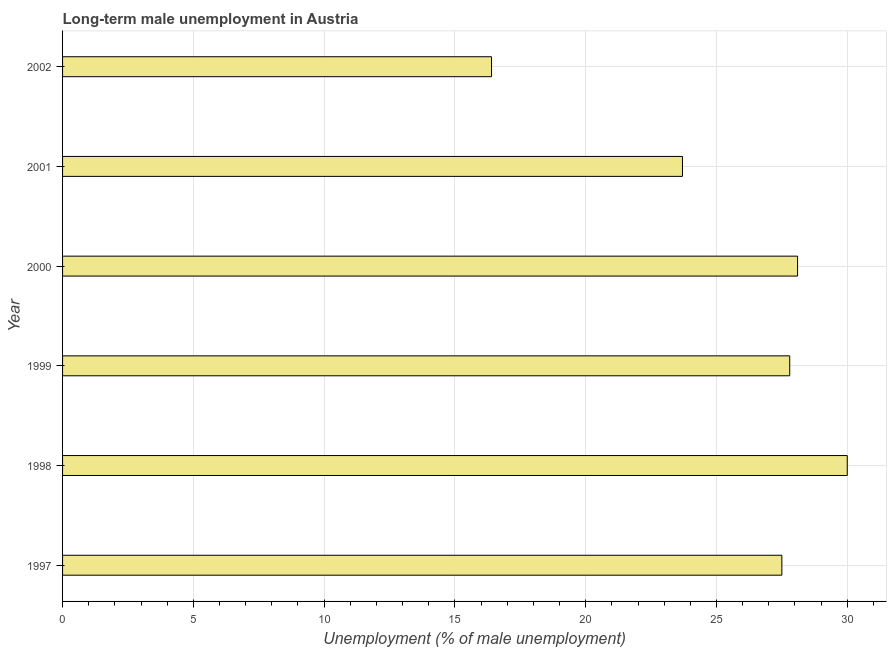Does the graph contain any zero values?
Your response must be concise. No. What is the title of the graph?
Provide a short and direct response. Long-term male unemployment in Austria. What is the label or title of the X-axis?
Your answer should be compact. Unemployment (% of male unemployment). What is the long-term male unemployment in 2000?
Offer a very short reply. 28.1. Across all years, what is the maximum long-term male unemployment?
Provide a succinct answer. 30. Across all years, what is the minimum long-term male unemployment?
Give a very brief answer. 16.4. In which year was the long-term male unemployment maximum?
Keep it short and to the point. 1998. What is the sum of the long-term male unemployment?
Give a very brief answer. 153.5. What is the difference between the long-term male unemployment in 1997 and 2000?
Your answer should be very brief. -0.6. What is the average long-term male unemployment per year?
Offer a terse response. 25.58. What is the median long-term male unemployment?
Provide a short and direct response. 27.65. Is the difference between the long-term male unemployment in 1997 and 1999 greater than the difference between any two years?
Make the answer very short. No. What is the difference between the highest and the lowest long-term male unemployment?
Provide a short and direct response. 13.6. In how many years, is the long-term male unemployment greater than the average long-term male unemployment taken over all years?
Give a very brief answer. 4. What is the difference between two consecutive major ticks on the X-axis?
Your answer should be very brief. 5. Are the values on the major ticks of X-axis written in scientific E-notation?
Your response must be concise. No. What is the Unemployment (% of male unemployment) of 1998?
Your answer should be compact. 30. What is the Unemployment (% of male unemployment) in 1999?
Keep it short and to the point. 27.8. What is the Unemployment (% of male unemployment) in 2000?
Offer a terse response. 28.1. What is the Unemployment (% of male unemployment) in 2001?
Give a very brief answer. 23.7. What is the Unemployment (% of male unemployment) in 2002?
Provide a succinct answer. 16.4. What is the difference between the Unemployment (% of male unemployment) in 1997 and 2001?
Give a very brief answer. 3.8. What is the difference between the Unemployment (% of male unemployment) in 1997 and 2002?
Provide a succinct answer. 11.1. What is the difference between the Unemployment (% of male unemployment) in 1998 and 2000?
Offer a very short reply. 1.9. What is the difference between the Unemployment (% of male unemployment) in 1998 and 2002?
Offer a very short reply. 13.6. What is the difference between the Unemployment (% of male unemployment) in 2000 and 2002?
Your answer should be compact. 11.7. What is the difference between the Unemployment (% of male unemployment) in 2001 and 2002?
Your answer should be very brief. 7.3. What is the ratio of the Unemployment (% of male unemployment) in 1997 to that in 1998?
Your answer should be very brief. 0.92. What is the ratio of the Unemployment (% of male unemployment) in 1997 to that in 2001?
Provide a short and direct response. 1.16. What is the ratio of the Unemployment (% of male unemployment) in 1997 to that in 2002?
Your answer should be compact. 1.68. What is the ratio of the Unemployment (% of male unemployment) in 1998 to that in 1999?
Offer a very short reply. 1.08. What is the ratio of the Unemployment (% of male unemployment) in 1998 to that in 2000?
Offer a very short reply. 1.07. What is the ratio of the Unemployment (% of male unemployment) in 1998 to that in 2001?
Offer a terse response. 1.27. What is the ratio of the Unemployment (% of male unemployment) in 1998 to that in 2002?
Give a very brief answer. 1.83. What is the ratio of the Unemployment (% of male unemployment) in 1999 to that in 2001?
Give a very brief answer. 1.17. What is the ratio of the Unemployment (% of male unemployment) in 1999 to that in 2002?
Your answer should be compact. 1.7. What is the ratio of the Unemployment (% of male unemployment) in 2000 to that in 2001?
Provide a short and direct response. 1.19. What is the ratio of the Unemployment (% of male unemployment) in 2000 to that in 2002?
Your response must be concise. 1.71. What is the ratio of the Unemployment (% of male unemployment) in 2001 to that in 2002?
Provide a short and direct response. 1.45. 